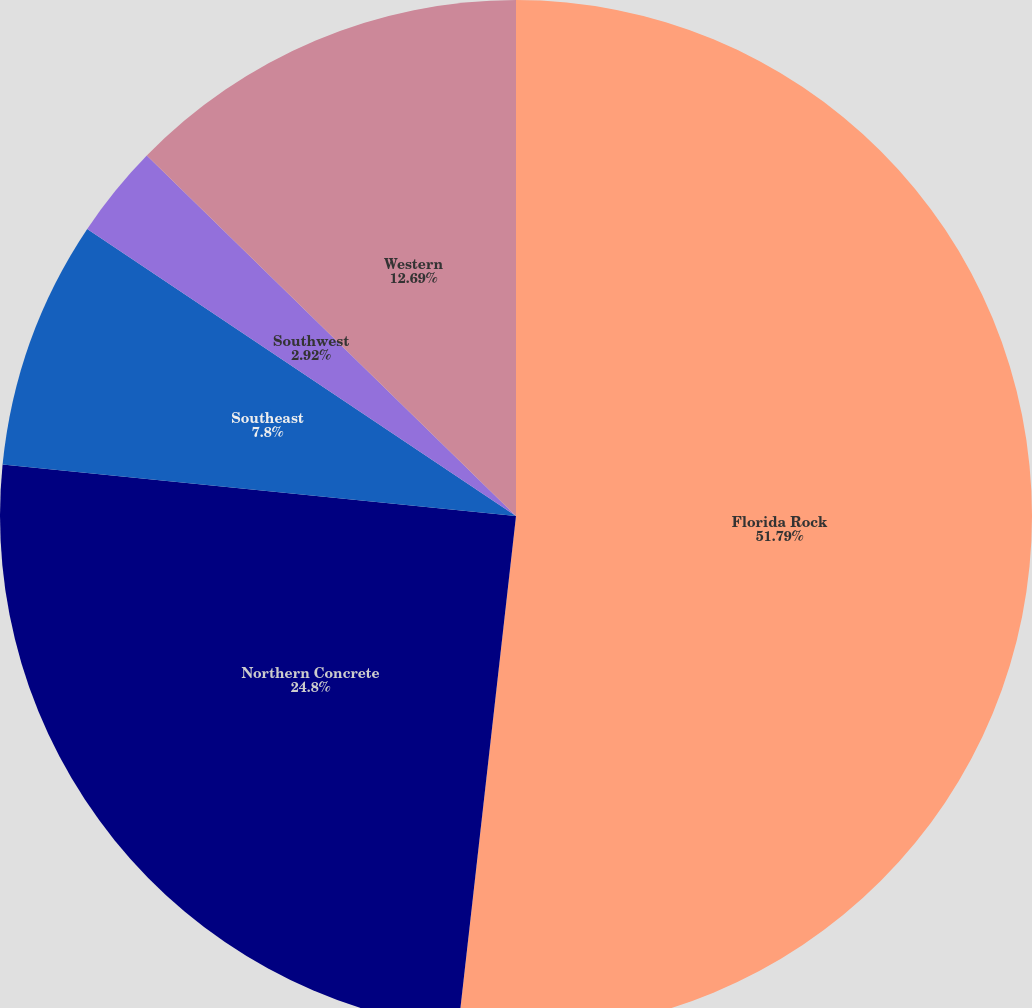<chart> <loc_0><loc_0><loc_500><loc_500><pie_chart><fcel>Florida Rock<fcel>Northern Concrete<fcel>Southeast<fcel>Southwest<fcel>Western<nl><fcel>51.79%<fcel>24.8%<fcel>7.8%<fcel>2.92%<fcel>12.69%<nl></chart> 